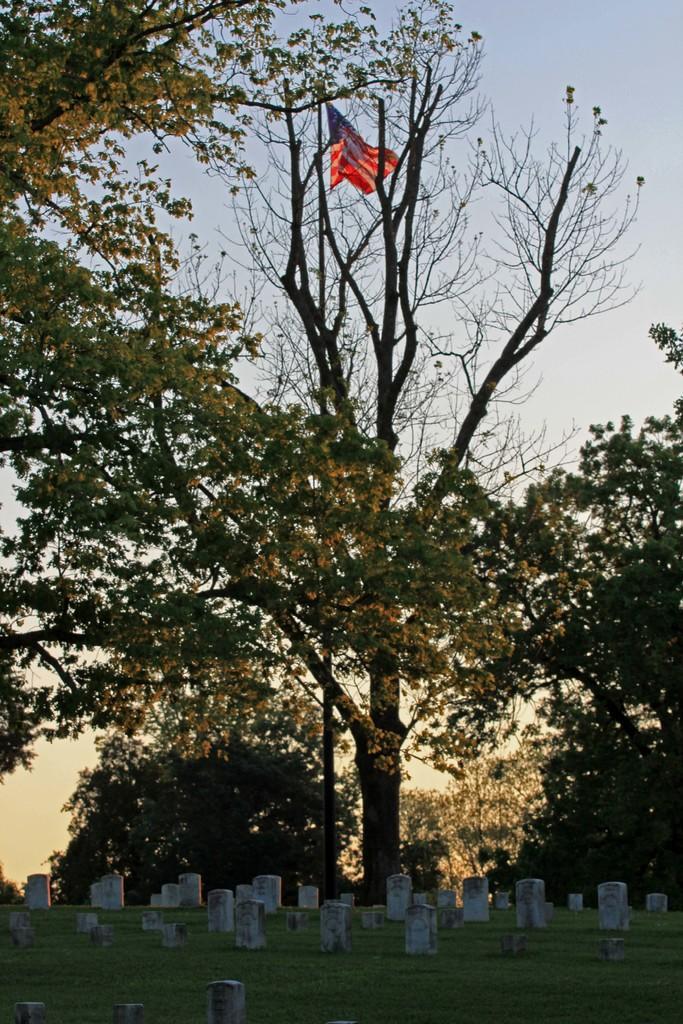Please provide a concise description of this image. At the bottom of the picture, we see the grass and the gravestones. In the middle, we see a flag pole and a flag in white, red and blue color. There are trees in the background. We see the sky in the background. 